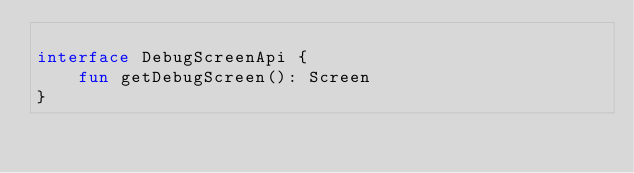Convert code to text. <code><loc_0><loc_0><loc_500><loc_500><_Kotlin_>
interface DebugScreenApi {
    fun getDebugScreen(): Screen
}
</code> 